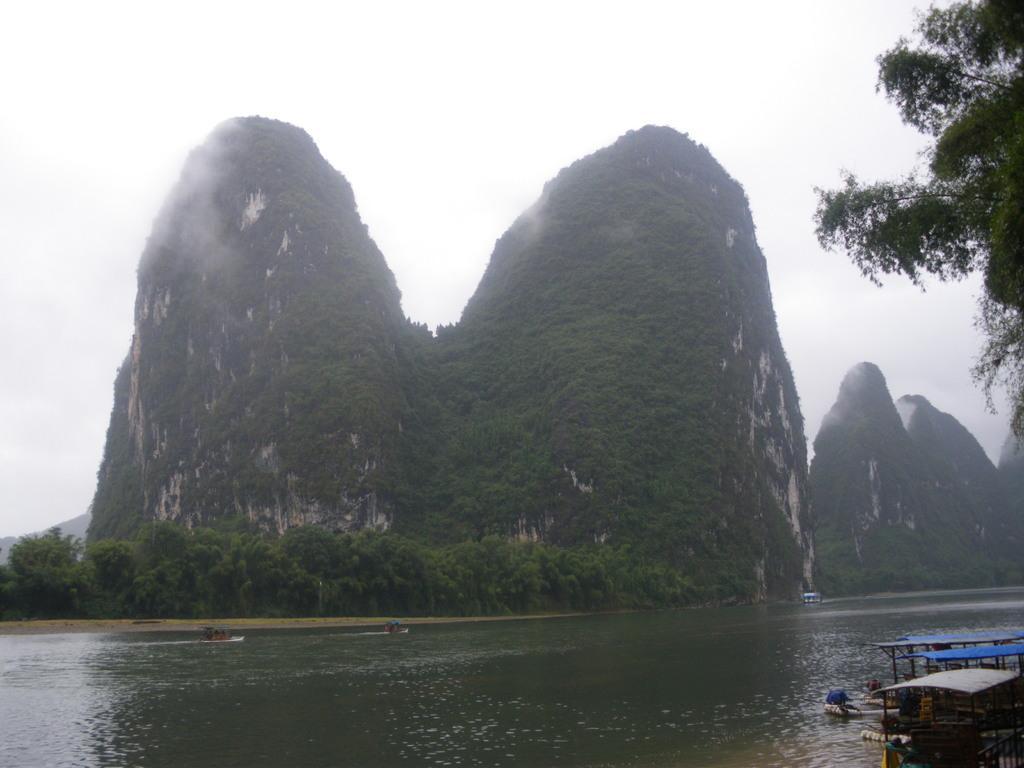Can you describe this image briefly? In the foreground of the image we can see water body and boats. In the middle of the image we can see the trees and hills. On the top of the image we can see the sky. 